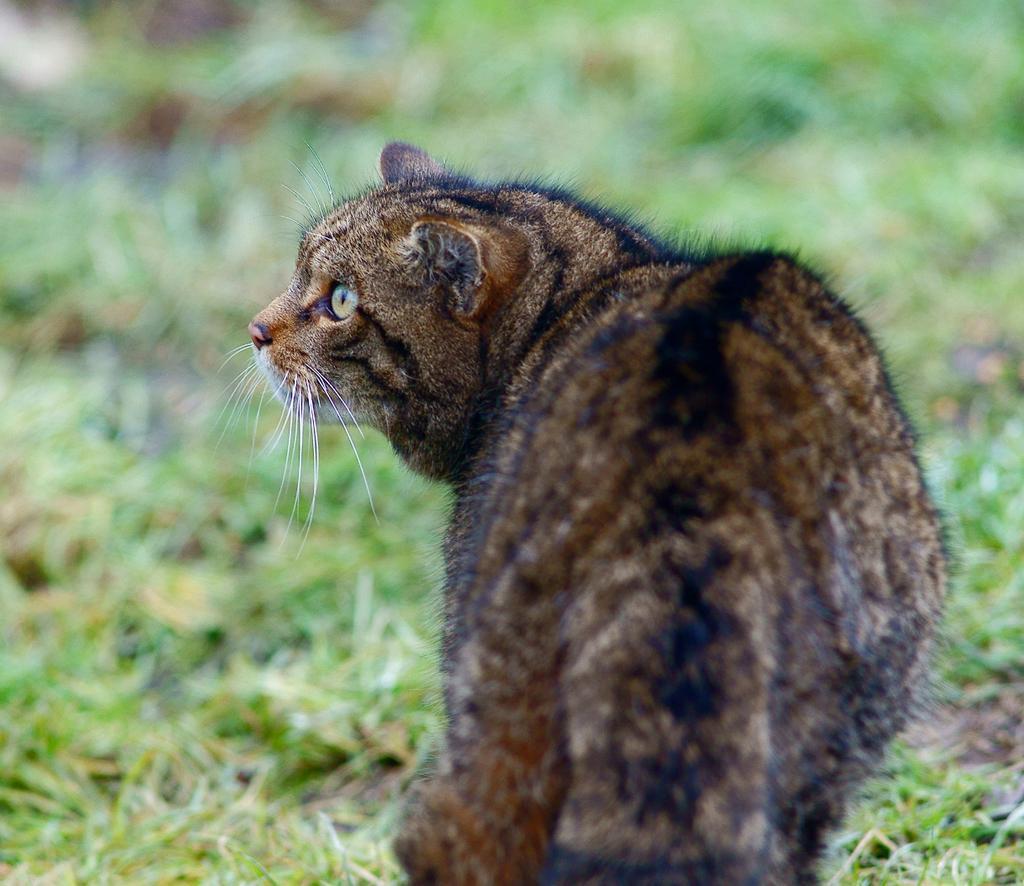How would you summarize this image in a sentence or two? In this image, we can see a cat. We can see the ground with some grass. We can also see the blurred background. 